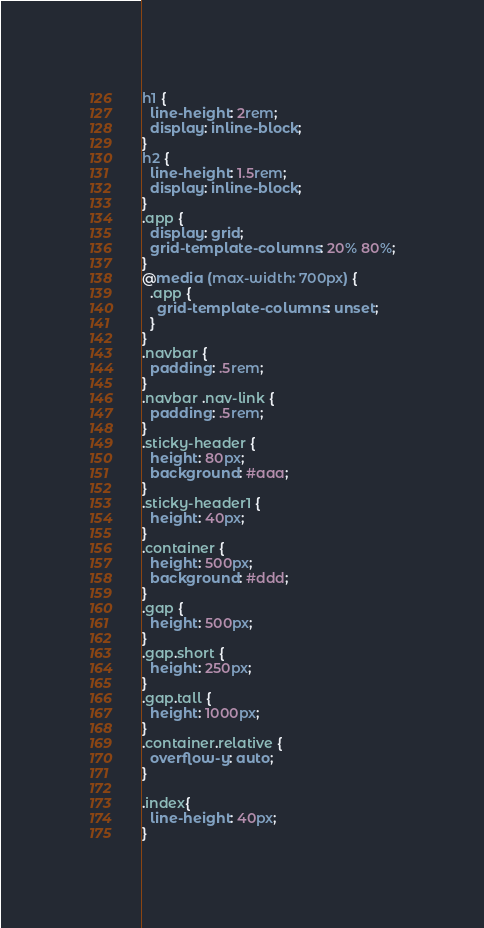Convert code to text. <code><loc_0><loc_0><loc_500><loc_500><_CSS_>h1 {
  line-height: 2rem;
  display: inline-block;
}
h2 {
  line-height: 1.5rem;
  display: inline-block;
}
.app {
  display: grid;
  grid-template-columns: 20% 80%;
}
@media (max-width: 700px) {
  .app {
    grid-template-columns: unset;
  }
}
.navbar {
  padding: .5rem;
}
.navbar .nav-link {
  padding: .5rem;
}
.sticky-header {
  height: 80px;
  background: #aaa;
}
.sticky-header1 {
  height: 40px;
}
.container {
  height: 500px;
  background: #ddd;
}
.gap {
  height: 500px;
}
.gap.short {
  height: 250px;
}
.gap.tall {
  height: 1000px;
}
.container.relative {
  overflow-y: auto;
}

.index{
  line-height: 40px;
}
</code> 